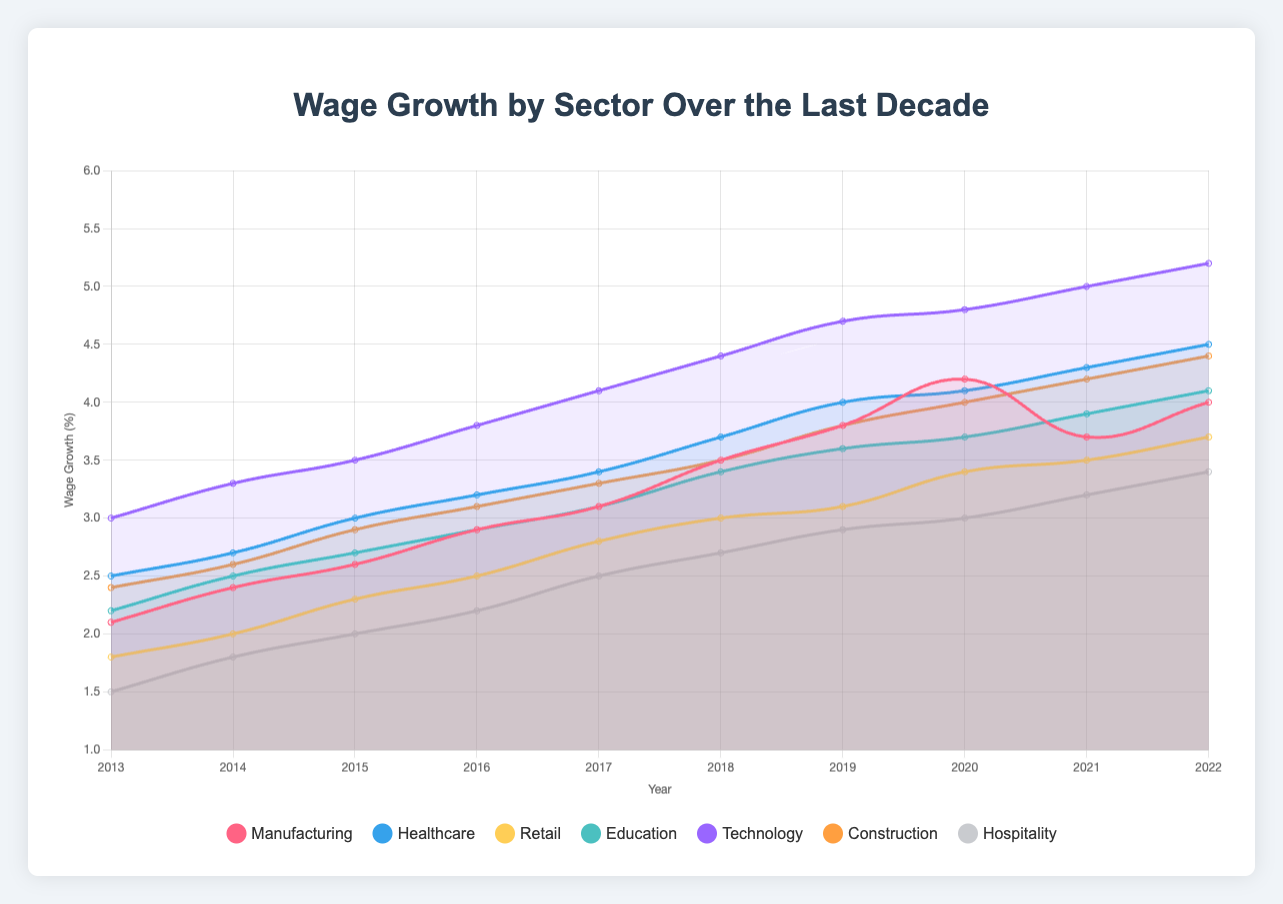What is the overall trend in wage growth for the Technology sector from 2013 to 2022? The wage growth in the Technology sector shows a steady increase from 3.0% in 2013 to 5.2% in 2022. By looking at the chart, we see the points consistently rising over the years, indicating continual wage growth.
Answer: Steady increase Which sector experienced the highest wage growth in 2022? By comparing the final data points for 2022 across all sectors, Technology has the highest wage growth at 5.2%.
Answer: Technology How does the wage growth in Healthcare in 2019 compare to that in Education in 2019? In 2019, the wage growth for Healthcare is 4.0% and for Education is 3.6%. Comparing these values shows that Healthcare had a higher wage growth than Education in 2019.
Answer: Healthcare is higher What is the difference in minimum wage compliance rate between Retail and Hospitality in 2020? The minimum wage compliance rate for Retail in 2020 is 93%, and for Hospitality, it is 92%. Subtracting these gives a difference of 1%.
Answer: 1% Which sectors had minimum wage compliance rates of 95% or higher consistently for all years? By examining the minimum wage compliance data, Manufacturing, Healthcare, Education, Technology, and Construction all have compliance rates of 95% or higher consistently for every year.
Answer: Manufacturing, Healthcare, Education, Technology, Construction Identify the sector with the lowest wage growth in 2015 and its corresponding value. The chart shows that Hospitality has the lowest wage growth in 2015 with a value of 2.0%.
Answer: Hospitality, 2.0% What is the average wage growth for the Manufacturing sector over the decade? Sum of wage growth for Manufacturing from 2013 to 2022: 2.1 + 2.4 + 2.6 + 2.9 + 3.1 + 3.5 + 3.8 + 4.2 + 3.7 + 4.0 = 33.3. Divide by 10 years: 33.3 / 10 = 3.33%.
Answer: 3.33% How did the wage growth in the Construction sector change from 2016 to 2019? The wage growth in Construction in 2016 was 3.1% and increased to 3.8% in 2019. The change is 3.8% - 3.1% = 0.7%.
Answer: Increased by 0.7% Which sector had the most significant decrease in wage growth from 2020 to 2021? By comparing the drop in wage growth between 2020 and 2021 for all sectors, Manufacturing had a decrease from 4.2% in 2020 to 3.7% in 2021, a drop of 0.5%, which is the largest decrease.
Answer: Manufacturing What was the combined minimum wage compliance rate for Manufacturing and Healthcare in 2017? The minimum wage compliance rate for Manufacturing in 2017 is 96%, and for Healthcare, it is 99%. Adding these together: 96% + 99% = 195%.
Answer: 195% 